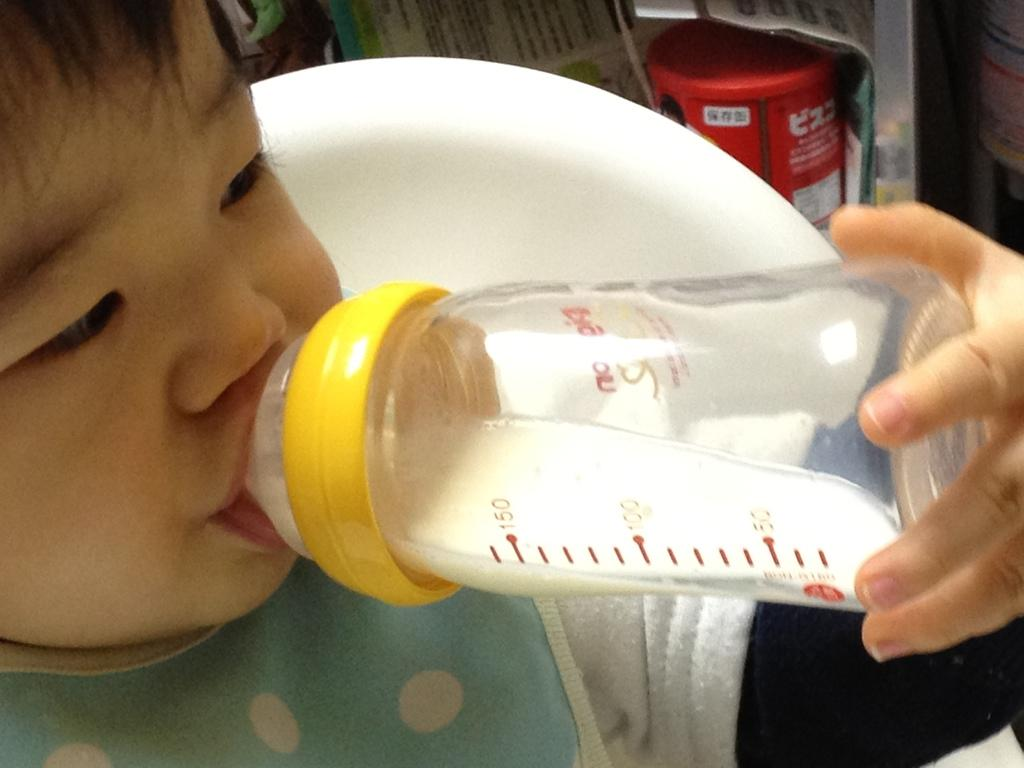What is the baby in the image doing? The baby is drinking milk from a bottle. What can be seen in the background of the image? There is a chair and a box in the background of the image. Are there any other people visible in the image? Yes, there is another person in the background of the image. What type of payment is being made to the baby in the image? There is no payment being made to the baby in the image; the baby is simply drinking milk from a bottle. 